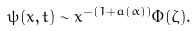<formula> <loc_0><loc_0><loc_500><loc_500>\psi ( x , t ) \sim x ^ { - ( 1 + a ( \alpha ) ) } \Phi ( \zeta ) .</formula> 